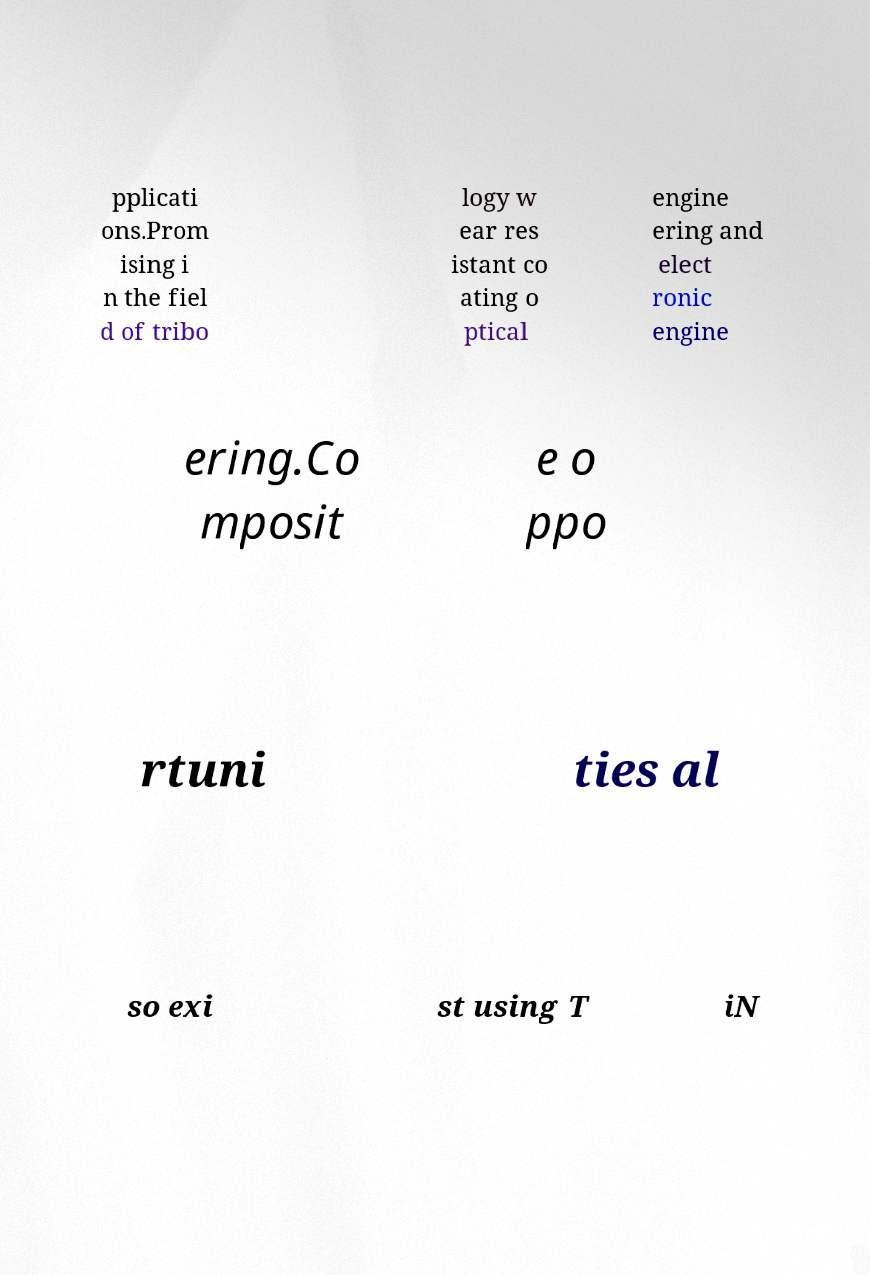Can you read and provide the text displayed in the image?This photo seems to have some interesting text. Can you extract and type it out for me? pplicati ons.Prom ising i n the fiel d of tribo logy w ear res istant co ating o ptical engine ering and elect ronic engine ering.Co mposit e o ppo rtuni ties al so exi st using T iN 